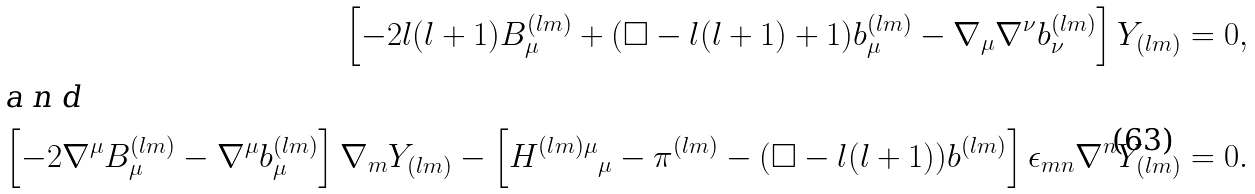<formula> <loc_0><loc_0><loc_500><loc_500>\left [ - 2 l ( l + 1 ) B ^ { ( l m ) } _ { \mu } + ( \Box - l ( l + 1 ) + 1 ) b ^ { ( l m ) } _ { \mu } - \nabla _ { \mu } \nabla ^ { \nu } b ^ { ( l m ) } _ { \nu } \right ] Y _ { ( l m ) } = 0 , \\ \intertext { a n d } \left [ - 2 \nabla ^ { \mu } B ^ { ( l m ) } _ { \mu } - \nabla ^ { \mu } b ^ { ( l m ) } _ { \mu } \right ] \nabla _ { m } Y _ { ( l m ) } - \left [ { H ^ { ( l m ) \mu } } _ { \mu } - \pi ^ { ( l m ) } - ( \Box - l ( l + 1 ) ) b ^ { ( l m ) } \right ] \epsilon _ { m n } \nabla ^ { n } Y _ { ( l m ) } = 0 .</formula> 